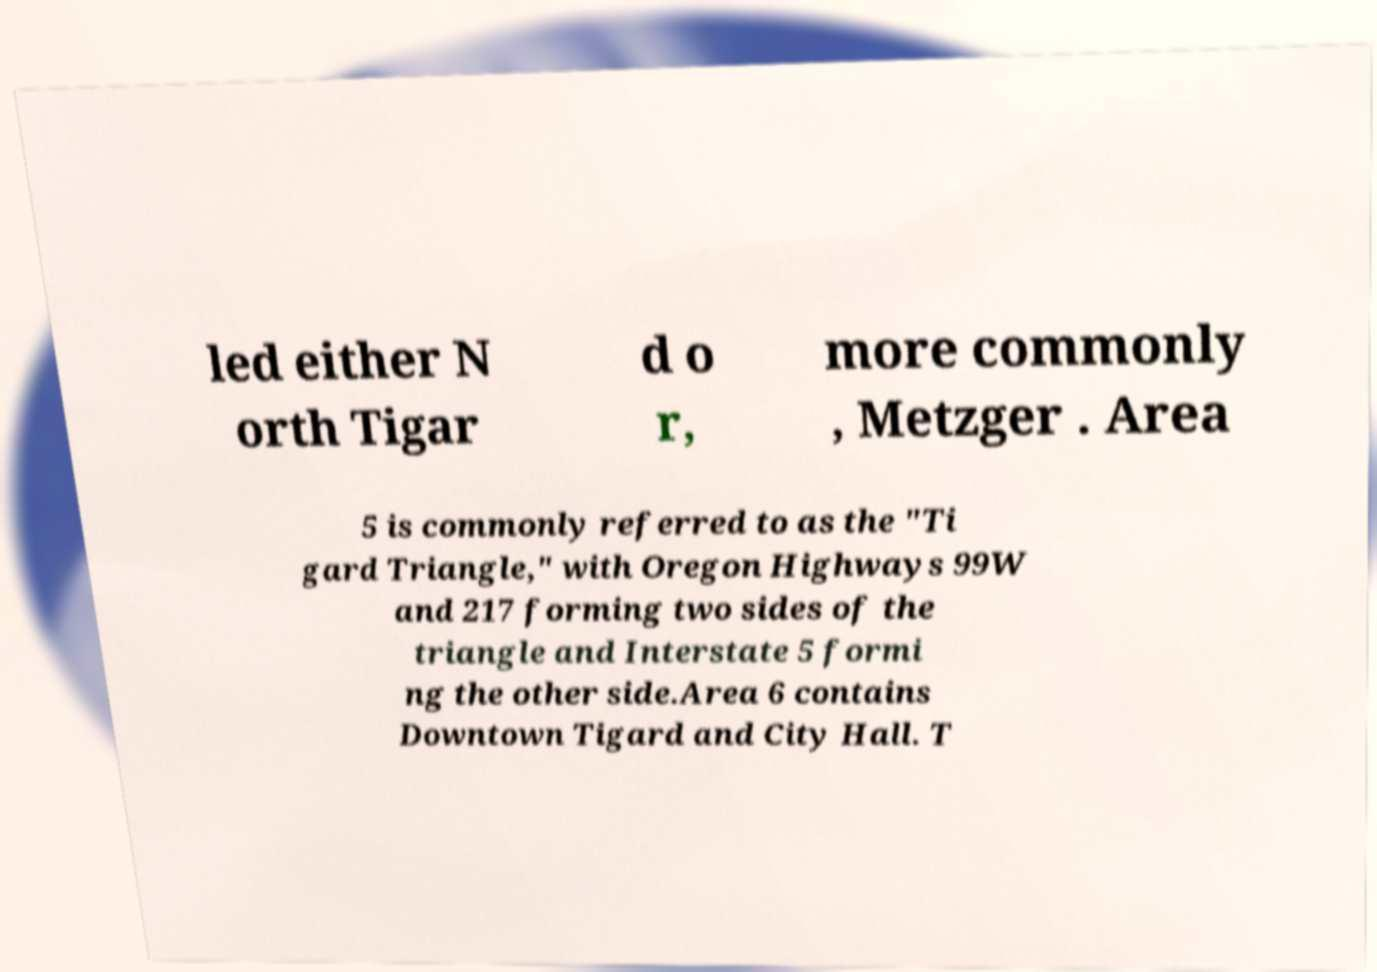Can you read and provide the text displayed in the image?This photo seems to have some interesting text. Can you extract and type it out for me? led either N orth Tigar d o r, more commonly , Metzger . Area 5 is commonly referred to as the "Ti gard Triangle," with Oregon Highways 99W and 217 forming two sides of the triangle and Interstate 5 formi ng the other side.Area 6 contains Downtown Tigard and City Hall. T 